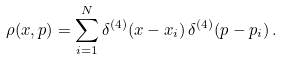Convert formula to latex. <formula><loc_0><loc_0><loc_500><loc_500>\rho ( x , p ) = \sum _ { i = 1 } ^ { N } \delta ^ { ( 4 ) } ( x - x _ { i } ) \, \delta ^ { ( 4 ) } ( p - p _ { i } ) \, .</formula> 